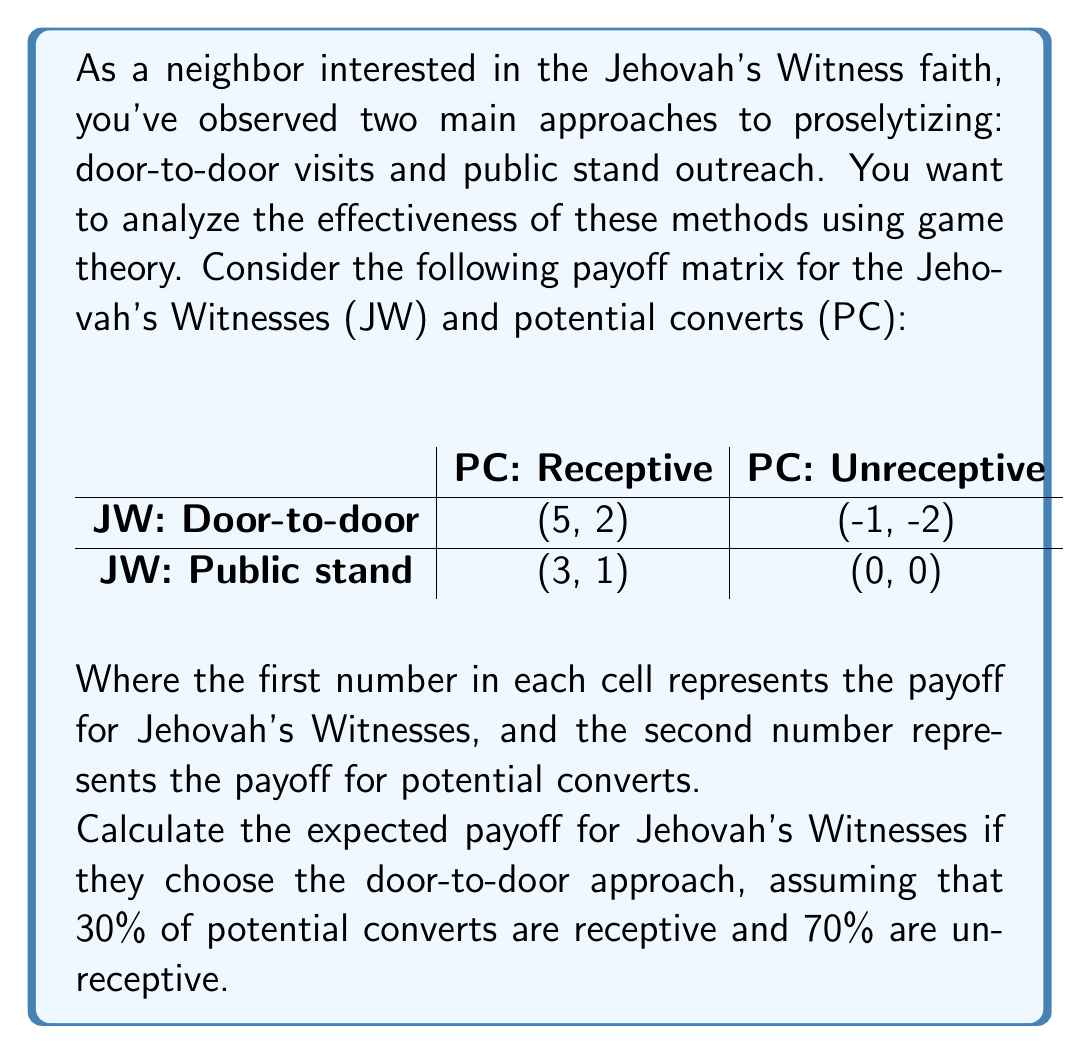Solve this math problem. To solve this problem, we need to use the concept of expected value from game theory. The expected payoff is calculated by multiplying each possible outcome by its probability and then summing these products.

Let's break it down step-by-step:

1) For the door-to-door approach, there are two possible outcomes:
   - Receptive potential convert: Payoff = 5
   - Unreceptive potential convert: Payoff = -1

2) The probabilities are:
   - Probability of a receptive convert: 30% = 0.3
   - Probability of an unreceptive convert: 70% = 0.7

3) Now, let's calculate the expected payoff:

   $E(\text{Door-to-door}) = (5 \times 0.3) + (-1 \times 0.7)$

4) Let's solve this equation:
   
   $E(\text{Door-to-door}) = 1.5 - 0.7 = 0.8$

Therefore, the expected payoff for Jehovah's Witnesses when choosing the door-to-door approach is 0.8.
Answer: The expected payoff for Jehovah's Witnesses using the door-to-door approach is 0.8. 